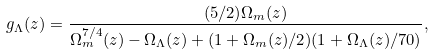Convert formula to latex. <formula><loc_0><loc_0><loc_500><loc_500>g _ { \Lambda } ( z ) = \frac { ( 5 / 2 ) \Omega _ { m } ( z ) } { \Omega _ { m } ^ { 7 / 4 } ( z ) - \Omega _ { \Lambda } ( z ) + ( 1 + \Omega _ { m } ( z ) / 2 ) ( 1 + \Omega _ { \Lambda } ( z ) / 7 0 ) } ,</formula> 